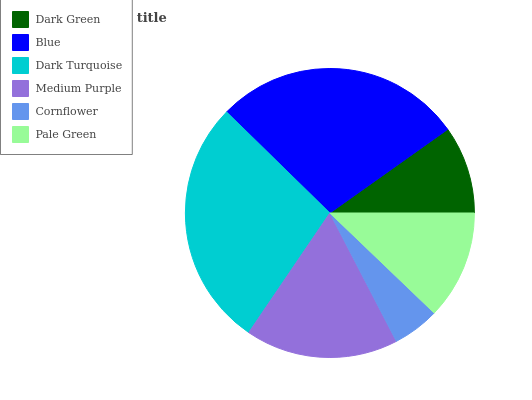Is Cornflower the minimum?
Answer yes or no. Yes. Is Blue the maximum?
Answer yes or no. Yes. Is Dark Turquoise the minimum?
Answer yes or no. No. Is Dark Turquoise the maximum?
Answer yes or no. No. Is Blue greater than Dark Turquoise?
Answer yes or no. Yes. Is Dark Turquoise less than Blue?
Answer yes or no. Yes. Is Dark Turquoise greater than Blue?
Answer yes or no. No. Is Blue less than Dark Turquoise?
Answer yes or no. No. Is Medium Purple the high median?
Answer yes or no. Yes. Is Pale Green the low median?
Answer yes or no. Yes. Is Cornflower the high median?
Answer yes or no. No. Is Dark Green the low median?
Answer yes or no. No. 